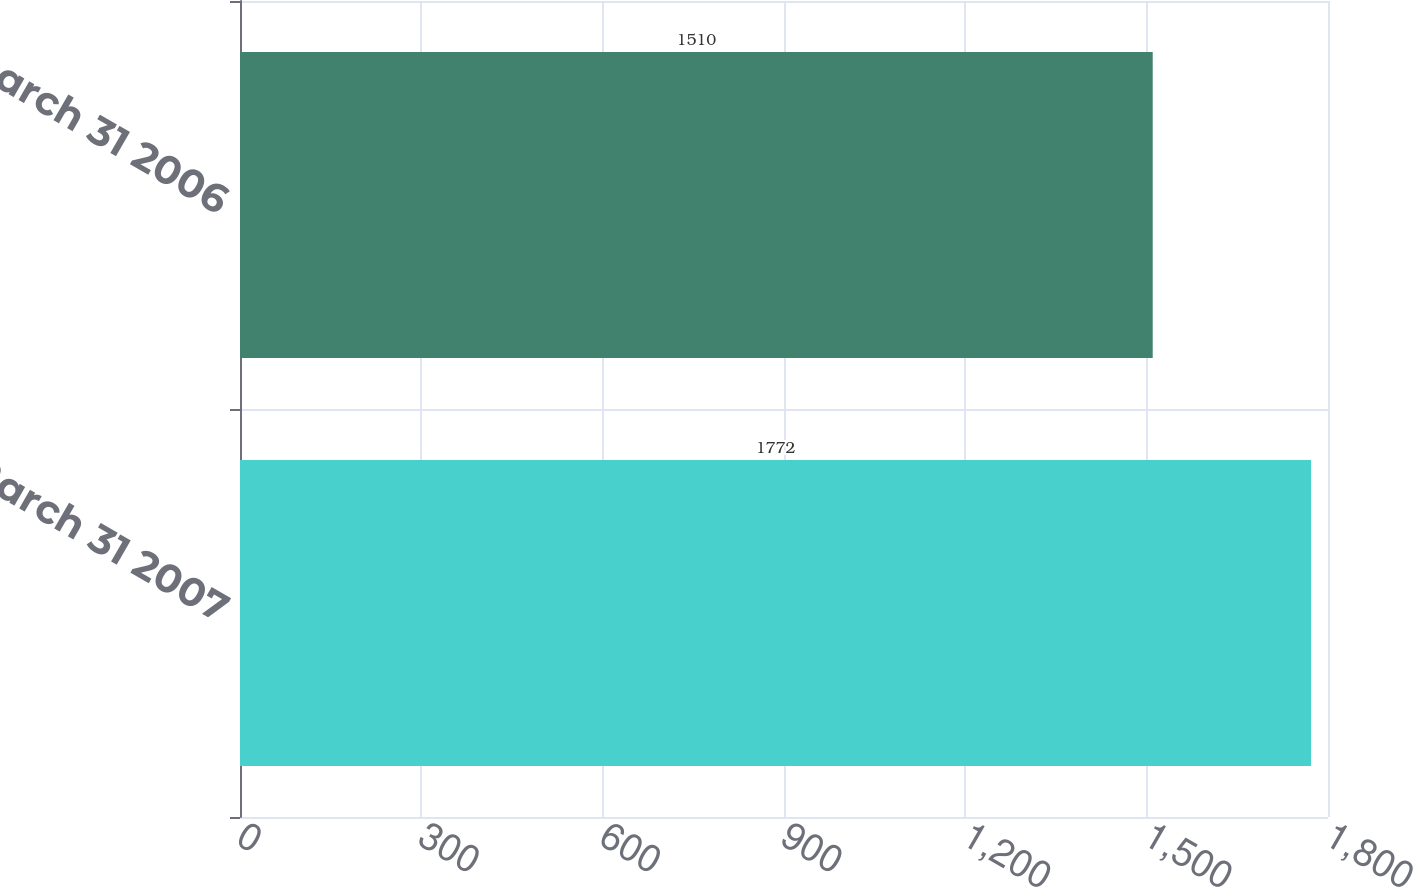Convert chart to OTSL. <chart><loc_0><loc_0><loc_500><loc_500><bar_chart><fcel>March 31 2007<fcel>March 31 2006<nl><fcel>1772<fcel>1510<nl></chart> 